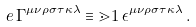Convert formula to latex. <formula><loc_0><loc_0><loc_500><loc_500>e \, \Gamma ^ { \mu \nu \rho \sigma \tau \kappa \lambda } & \equiv \mathbb { m } { 1 } \, \epsilon ^ { \mu \nu \rho \sigma \tau \kappa \lambda } \, .</formula> 